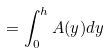Convert formula to latex. <formula><loc_0><loc_0><loc_500><loc_500>= \int _ { 0 } ^ { h } A ( y ) d y</formula> 